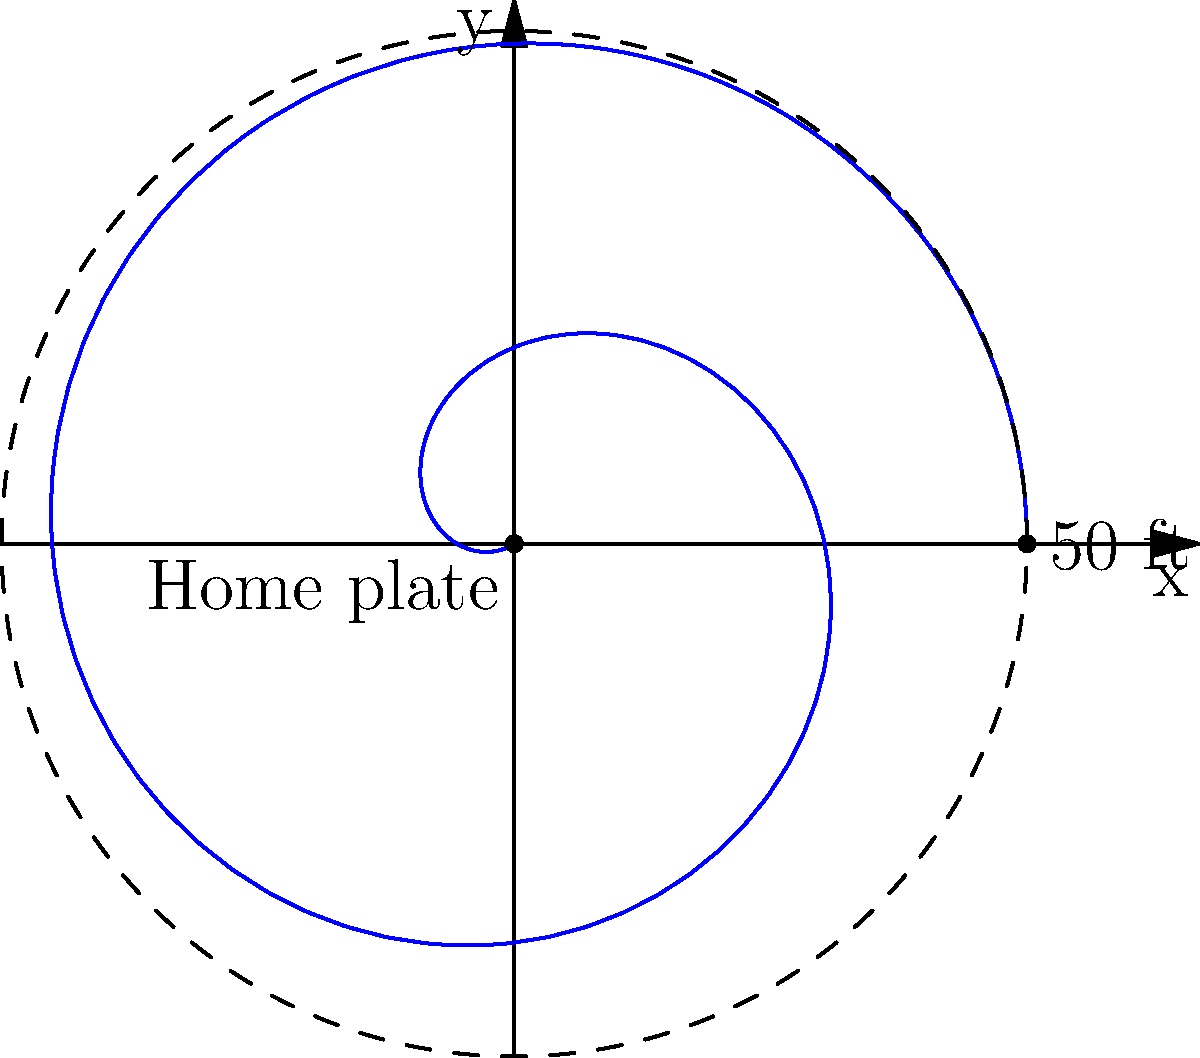As a local sports reporter, you're analyzing a pitcher's curveball. The trajectory of the pitch can be modeled in polar coordinates by the equation $r = 50 - 0.5\theta^2$, where $r$ is in feet and $\theta$ is in radians. At what angle $\theta$ (in radians) does the ball cross home plate, assuming the pitcher releases the ball at a distance of 50 feet? To solve this problem, we need to follow these steps:

1) The ball crosses home plate when $r = 0$. So we need to solve the equation:

   $0 = 50 - 0.5\theta^2$

2) Rearranging the equation:

   $0.5\theta^2 = 50$

3) Multiply both sides by 2:

   $\theta^2 = 100$

4) Take the square root of both sides:

   $\theta = \sqrt{100} = 10$

5) Since we're dealing with a physical situation, we only consider the positive solution.

Therefore, the ball crosses home plate when $\theta = 10$ radians.
Answer: $10$ radians 